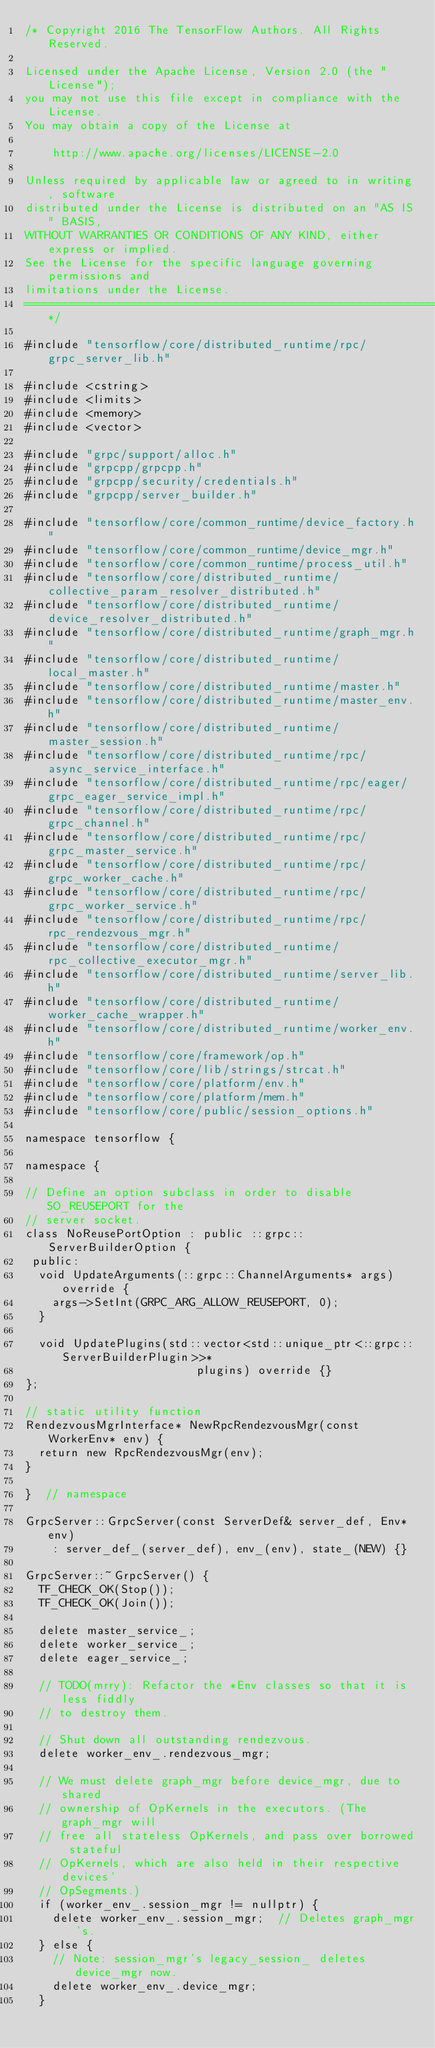<code> <loc_0><loc_0><loc_500><loc_500><_C++_>/* Copyright 2016 The TensorFlow Authors. All Rights Reserved.

Licensed under the Apache License, Version 2.0 (the "License");
you may not use this file except in compliance with the License.
You may obtain a copy of the License at

    http://www.apache.org/licenses/LICENSE-2.0

Unless required by applicable law or agreed to in writing, software
distributed under the License is distributed on an "AS IS" BASIS,
WITHOUT WARRANTIES OR CONDITIONS OF ANY KIND, either express or implied.
See the License for the specific language governing permissions and
limitations under the License.
==============================================================================*/

#include "tensorflow/core/distributed_runtime/rpc/grpc_server_lib.h"

#include <cstring>
#include <limits>
#include <memory>
#include <vector>

#include "grpc/support/alloc.h"
#include "grpcpp/grpcpp.h"
#include "grpcpp/security/credentials.h"
#include "grpcpp/server_builder.h"

#include "tensorflow/core/common_runtime/device_factory.h"
#include "tensorflow/core/common_runtime/device_mgr.h"
#include "tensorflow/core/common_runtime/process_util.h"
#include "tensorflow/core/distributed_runtime/collective_param_resolver_distributed.h"
#include "tensorflow/core/distributed_runtime/device_resolver_distributed.h"
#include "tensorflow/core/distributed_runtime/graph_mgr.h"
#include "tensorflow/core/distributed_runtime/local_master.h"
#include "tensorflow/core/distributed_runtime/master.h"
#include "tensorflow/core/distributed_runtime/master_env.h"
#include "tensorflow/core/distributed_runtime/master_session.h"
#include "tensorflow/core/distributed_runtime/rpc/async_service_interface.h"
#include "tensorflow/core/distributed_runtime/rpc/eager/grpc_eager_service_impl.h"
#include "tensorflow/core/distributed_runtime/rpc/grpc_channel.h"
#include "tensorflow/core/distributed_runtime/rpc/grpc_master_service.h"
#include "tensorflow/core/distributed_runtime/rpc/grpc_worker_cache.h"
#include "tensorflow/core/distributed_runtime/rpc/grpc_worker_service.h"
#include "tensorflow/core/distributed_runtime/rpc/rpc_rendezvous_mgr.h"
#include "tensorflow/core/distributed_runtime/rpc_collective_executor_mgr.h"
#include "tensorflow/core/distributed_runtime/server_lib.h"
#include "tensorflow/core/distributed_runtime/worker_cache_wrapper.h"
#include "tensorflow/core/distributed_runtime/worker_env.h"
#include "tensorflow/core/framework/op.h"
#include "tensorflow/core/lib/strings/strcat.h"
#include "tensorflow/core/platform/env.h"
#include "tensorflow/core/platform/mem.h"
#include "tensorflow/core/public/session_options.h"

namespace tensorflow {

namespace {

// Define an option subclass in order to disable SO_REUSEPORT for the
// server socket.
class NoReusePortOption : public ::grpc::ServerBuilderOption {
 public:
  void UpdateArguments(::grpc::ChannelArguments* args) override {
    args->SetInt(GRPC_ARG_ALLOW_REUSEPORT, 0);
  }

  void UpdatePlugins(std::vector<std::unique_ptr<::grpc::ServerBuilderPlugin>>*
                         plugins) override {}
};

// static utility function
RendezvousMgrInterface* NewRpcRendezvousMgr(const WorkerEnv* env) {
  return new RpcRendezvousMgr(env);
}

}  // namespace

GrpcServer::GrpcServer(const ServerDef& server_def, Env* env)
    : server_def_(server_def), env_(env), state_(NEW) {}

GrpcServer::~GrpcServer() {
  TF_CHECK_OK(Stop());
  TF_CHECK_OK(Join());

  delete master_service_;
  delete worker_service_;
  delete eager_service_;

  // TODO(mrry): Refactor the *Env classes so that it is less fiddly
  // to destroy them.

  // Shut down all outstanding rendezvous.
  delete worker_env_.rendezvous_mgr;

  // We must delete graph_mgr before device_mgr, due to shared
  // ownership of OpKernels in the executors. (The graph_mgr will
  // free all stateless OpKernels, and pass over borrowed stateful
  // OpKernels, which are also held in their respective devices'
  // OpSegments.)
  if (worker_env_.session_mgr != nullptr) {
    delete worker_env_.session_mgr;  // Deletes graph_mgr's.
  } else {
    // Note: session_mgr's legacy_session_ deletes device_mgr now.
    delete worker_env_.device_mgr;
  }
</code> 